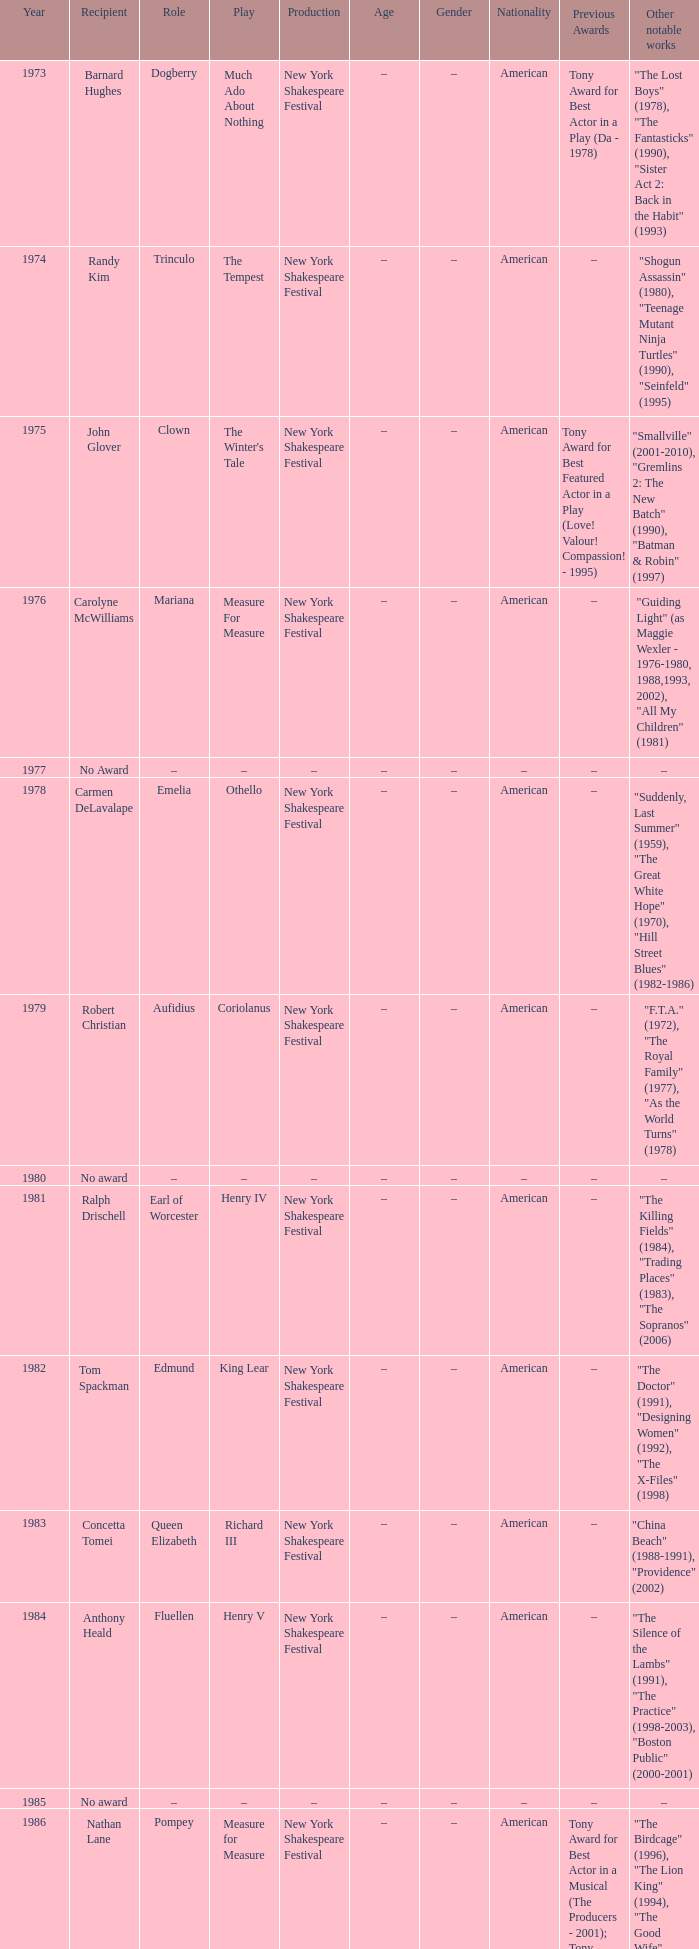Name the play for 1976 Measure For Measure. 